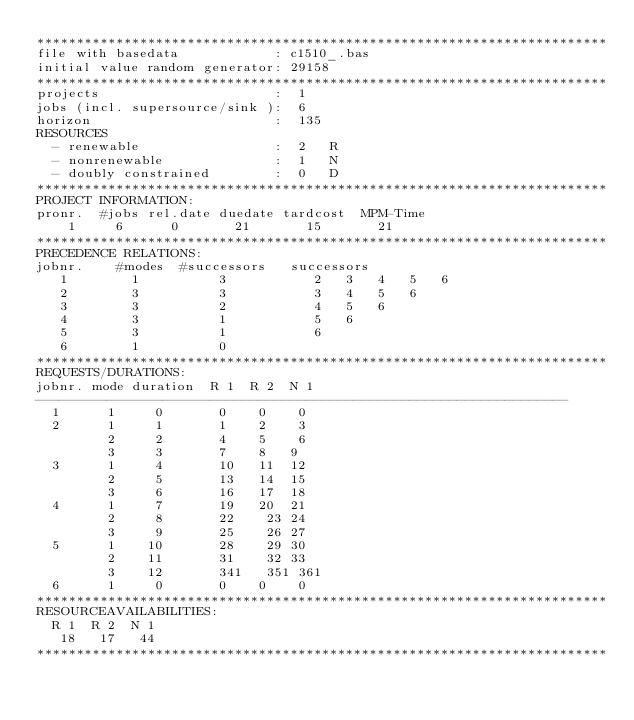Convert code to text. <code><loc_0><loc_0><loc_500><loc_500><_ObjectiveC_>************************************************************************
file with basedata            : c1510_.bas
initial value random generator: 29158
************************************************************************
projects                      :  1
jobs (incl. supersource/sink ):  6
horizon                       :  135
RESOURCES
  - renewable                 :  2   R
  - nonrenewable              :  1   N
  - doubly constrained        :  0   D
************************************************************************
PROJECT INFORMATION:
pronr.  #jobs rel.date duedate tardcost  MPM-Time
    1     6      0       21       15       21
************************************************************************
PRECEDENCE RELATIONS:
jobnr.    #modes  #successors   successors
   1        1          3           2   3   4   5   6
   2        3          3           3   4   5   6
   3        3          2           4   5   6
   4        3          1           5   6
   5        3          1           6
   6        1          0        
************************************************************************
REQUESTS/DURATIONS:
jobnr. mode duration  R 1  R 2  N 1
-------------------------------------------------------------------
  1      1     0       0    0    0
  2      1     1       1    2    3
         2     2       4    5    6
         3     3       7    8   9
  3      1     4       10   11  12
         2     5       13   14  15
         3     6       16   17  18
  4      1     7       19   20  21
         2     8       22    23 24
         3     9       25    26 27
  5      1    10       28    29 30
         2    11       31    32 33
         3    12       341   351 361
  6      1     0       0    0    0
************************************************************************
RESOURCEAVAILABILITIES:
  R 1  R 2  N 1
   18   17   44
************************************************************************
</code> 